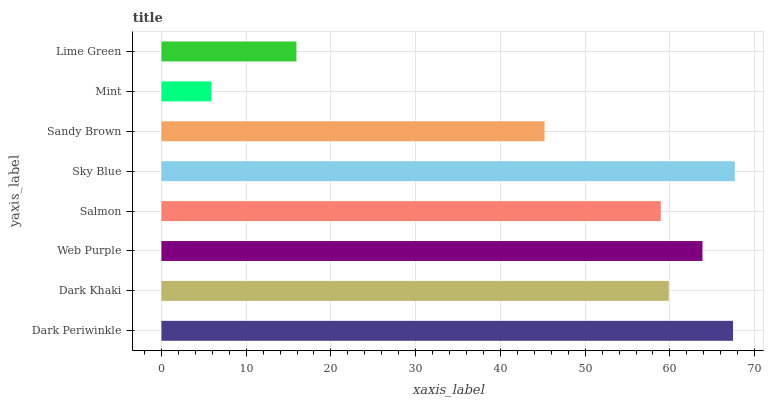Is Mint the minimum?
Answer yes or no. Yes. Is Sky Blue the maximum?
Answer yes or no. Yes. Is Dark Khaki the minimum?
Answer yes or no. No. Is Dark Khaki the maximum?
Answer yes or no. No. Is Dark Periwinkle greater than Dark Khaki?
Answer yes or no. Yes. Is Dark Khaki less than Dark Periwinkle?
Answer yes or no. Yes. Is Dark Khaki greater than Dark Periwinkle?
Answer yes or no. No. Is Dark Periwinkle less than Dark Khaki?
Answer yes or no. No. Is Dark Khaki the high median?
Answer yes or no. Yes. Is Salmon the low median?
Answer yes or no. Yes. Is Mint the high median?
Answer yes or no. No. Is Dark Periwinkle the low median?
Answer yes or no. No. 